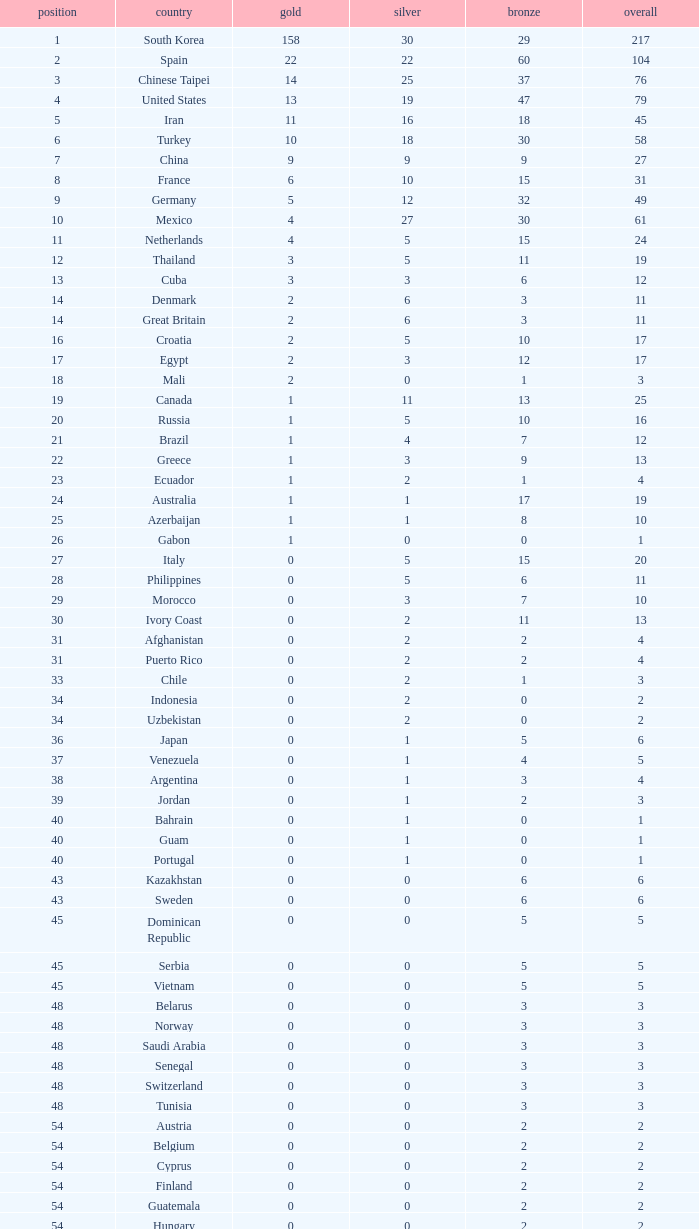What is the Total medals for the Nation ranking 33 with more than 1 Bronze? None. 